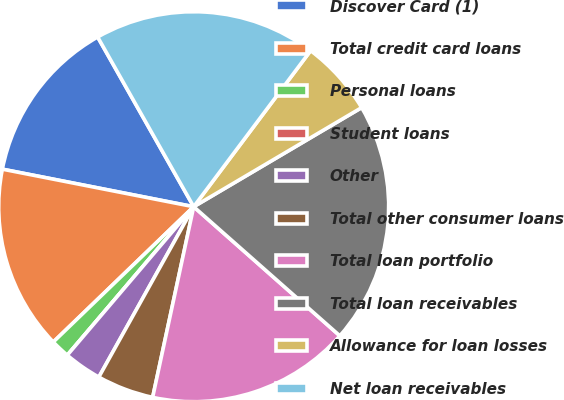Convert chart. <chart><loc_0><loc_0><loc_500><loc_500><pie_chart><fcel>Discover Card (1)<fcel>Total credit card loans<fcel>Personal loans<fcel>Student loans<fcel>Other<fcel>Total other consumer loans<fcel>Total loan portfolio<fcel>Total loan receivables<fcel>Allowance for loan losses<fcel>Net loan receivables<nl><fcel>13.72%<fcel>15.29%<fcel>1.57%<fcel>0.0%<fcel>3.14%<fcel>4.71%<fcel>16.86%<fcel>20.0%<fcel>6.28%<fcel>18.43%<nl></chart> 